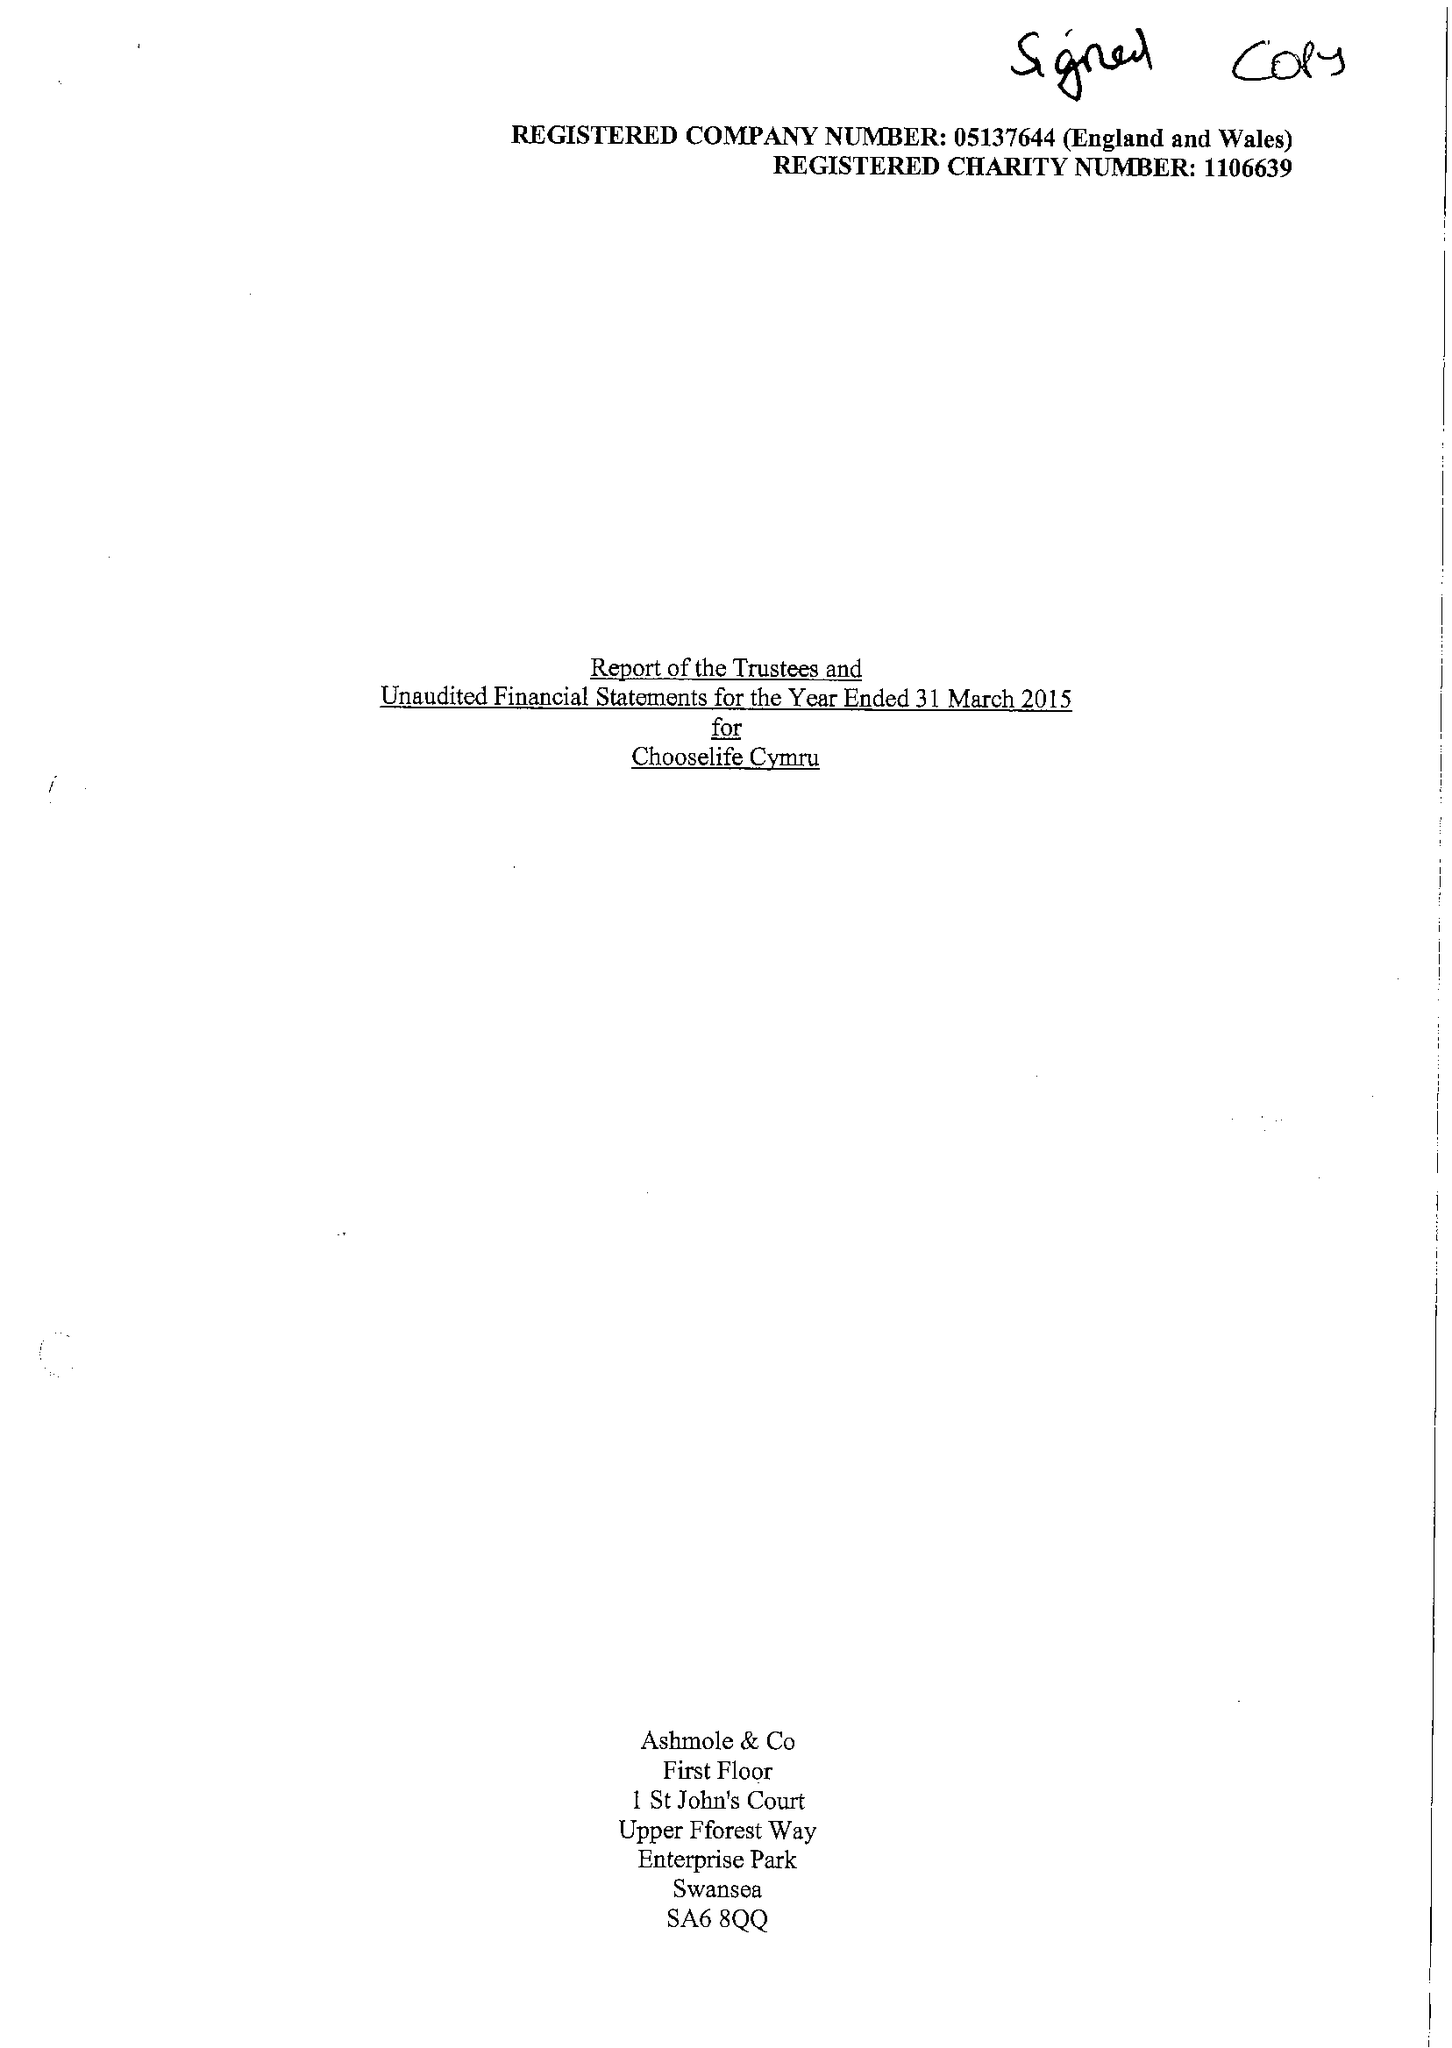What is the value for the address__street_line?
Answer the question using a single word or phrase. None 